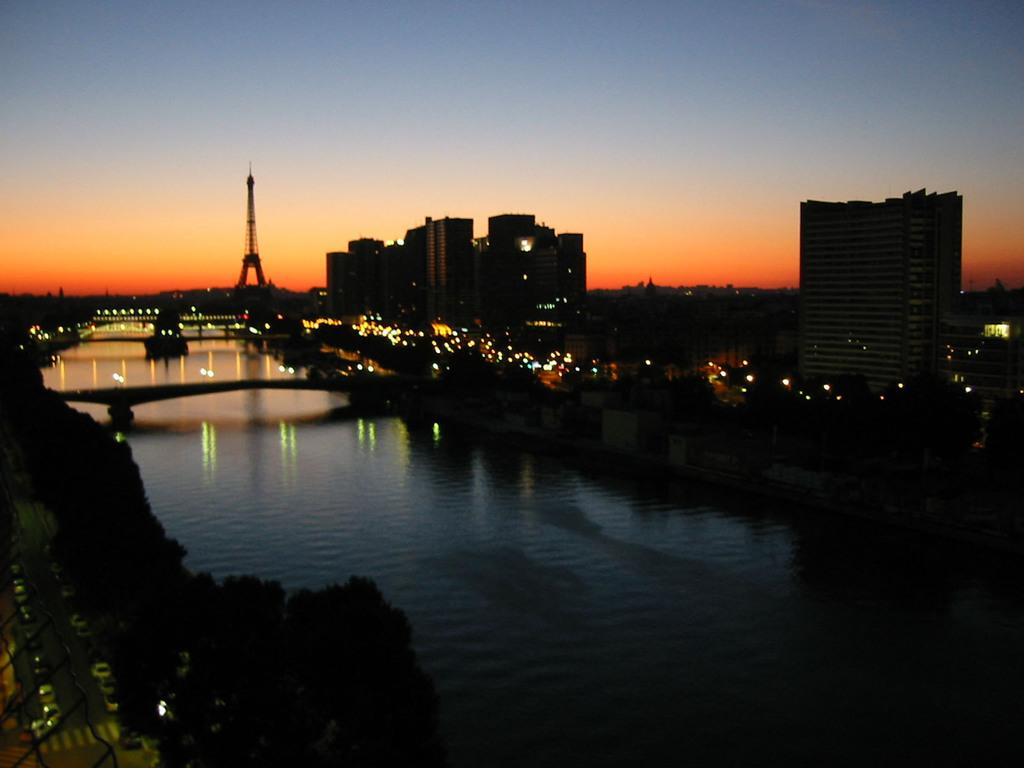What type of structures can be seen in the image? There are buildings in the image. What else is visible in the image besides the buildings? There are lights, water, a tower, and the sky visible in the image. Can you describe the water in the image? The water is visible in the image, but its specific characteristics are not mentioned in the facts}. What is the condition of the sky in the image? The sky is visible in the background of the image, and it appears to be a bit dark. What type of yam is being used to decorate the tower in the image? There is no yam present in the image, and the tower is not being decorated with any yam. Can you see a flock of birds flying over the buildings in the image? There is no mention of birds or a flock in the image, so we cannot determine if they are present or not. 